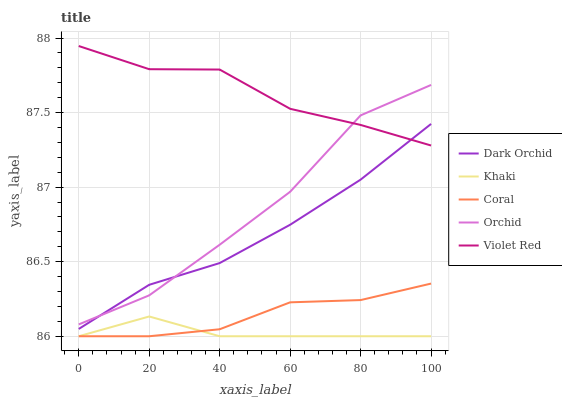Does Khaki have the minimum area under the curve?
Answer yes or no. Yes. Does Violet Red have the maximum area under the curve?
Answer yes or no. Yes. Does Violet Red have the minimum area under the curve?
Answer yes or no. No. Does Khaki have the maximum area under the curve?
Answer yes or no. No. Is Dark Orchid the smoothest?
Answer yes or no. Yes. Is Orchid the roughest?
Answer yes or no. Yes. Is Khaki the smoothest?
Answer yes or no. No. Is Khaki the roughest?
Answer yes or no. No. Does Coral have the lowest value?
Answer yes or no. Yes. Does Violet Red have the lowest value?
Answer yes or no. No. Does Violet Red have the highest value?
Answer yes or no. Yes. Does Khaki have the highest value?
Answer yes or no. No. Is Khaki less than Dark Orchid?
Answer yes or no. Yes. Is Violet Red greater than Khaki?
Answer yes or no. Yes. Does Violet Red intersect Dark Orchid?
Answer yes or no. Yes. Is Violet Red less than Dark Orchid?
Answer yes or no. No. Is Violet Red greater than Dark Orchid?
Answer yes or no. No. Does Khaki intersect Dark Orchid?
Answer yes or no. No. 